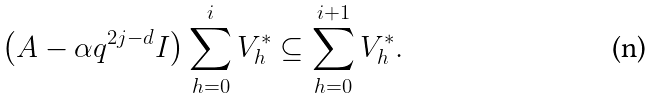<formula> <loc_0><loc_0><loc_500><loc_500>\left ( A - \alpha q ^ { 2 j - d } I \right ) \sum _ { h = 0 } ^ { i } V ^ { * } _ { h } \subseteq \sum _ { h = 0 } ^ { i + 1 } V ^ { * } _ { h } .</formula> 